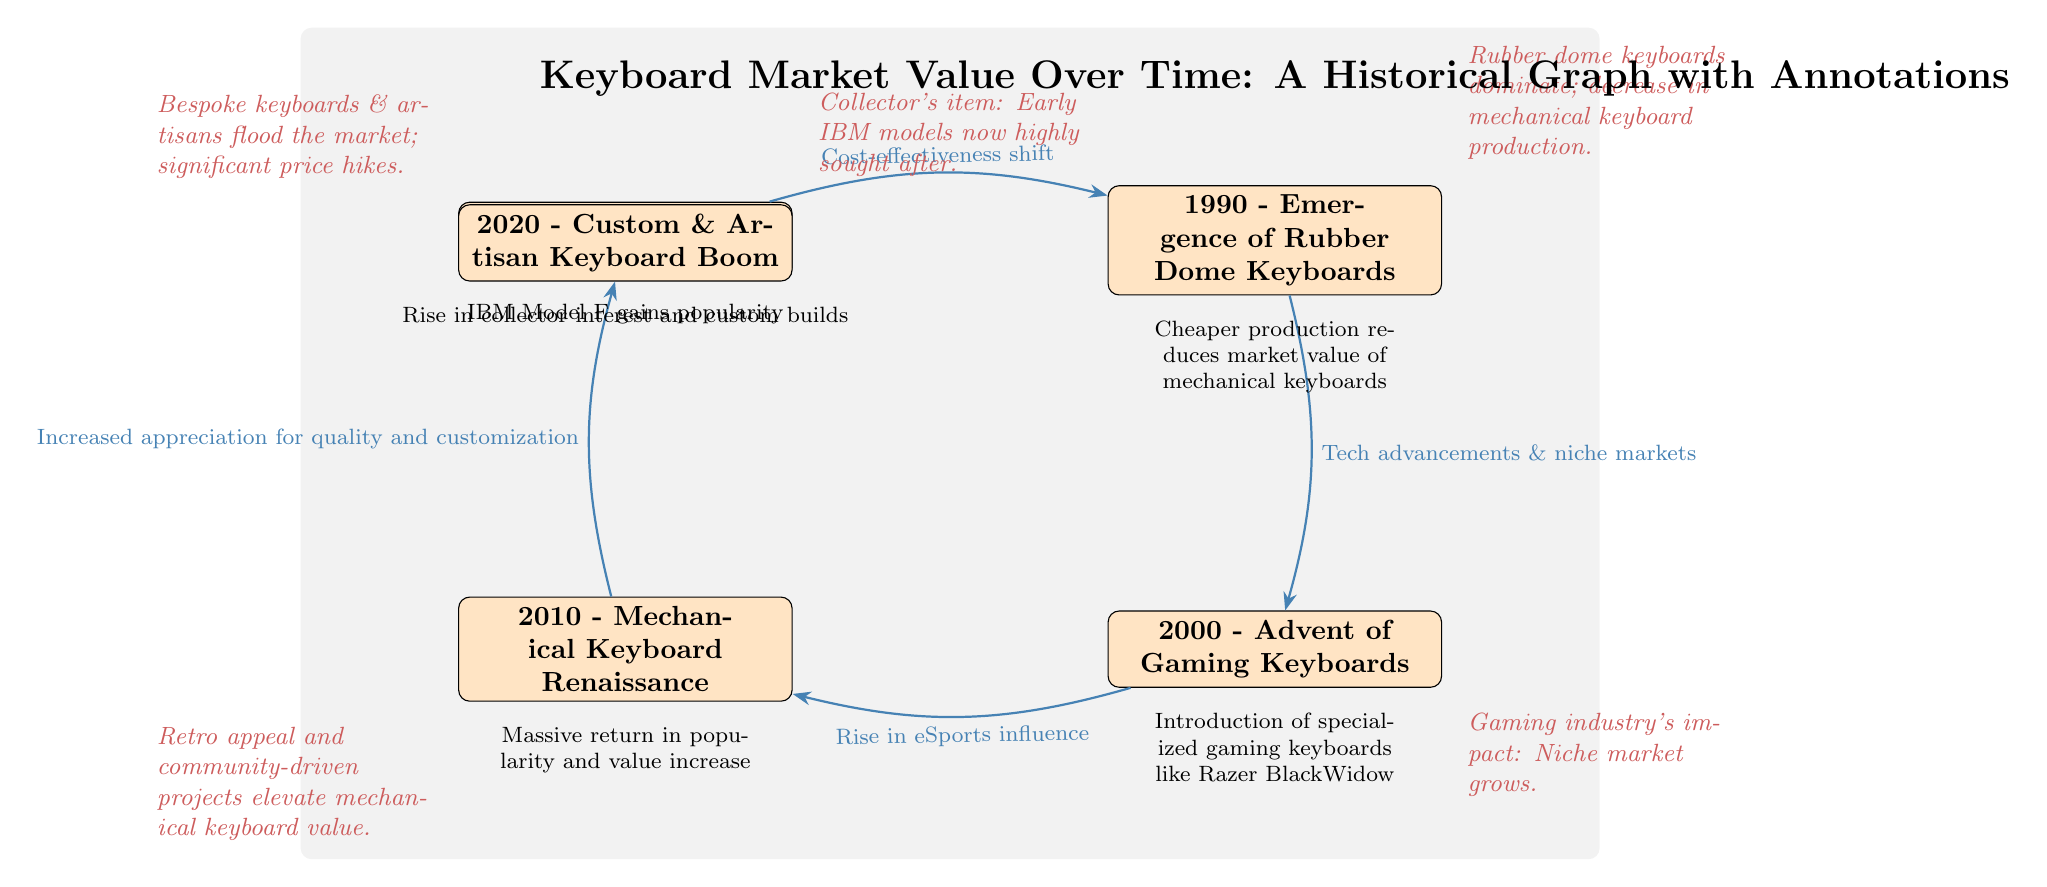What year marks the rise of mechanical keyboards? The diagram indicates 1980 as the year when mechanical keyboards began to rise in popularity.
Answer: 1980 How many nodes are displayed in the diagram? The diagram contains five nodes representing different years related to keyboard market trends.
Answer: 5 What keyword describes the market shift in 1990? The edge connecting 1980 to 1990 indicates a "Cost-effectiveness shift," which characterizes the market trend during that time.
Answer: Cost-effectiveness shift Which keyboard type emerged in the year 2000? The annotation next to the 2000 node states that there was an advent of gaming keyboards during that year.
Answer: Gaming Keyboards What significant market factor influenced keyboard values in 2010? The diagram's edge from 2000 to 2010 shows that the rise in eSports influence significantly impacted keyboard values during this period.
Answer: eSports influence What is noted about early IBM models? The annotation near 1980 highlights that early IBM models became highly sought after as collector's items.
Answer: Highly sought after Which event led to a value increase in mechanical keyboards around 2010? The edge connecting 2010 highlights that the increased appreciation for quality and customization raised the value of mechanical keyboards.
Answer: Increased appreciation for quality and customization How has the market changed by 2020 according to the annotations? The 2020 annotation points out that the market saw a flood of bespoke keyboards and artisans, leading to significant price hikes.
Answer: Significant price hikes What trend influenced the market after 2010? The diagram notes that, after 2010, there was a massive return in popularity and an increase in value for mechanical keyboards.
Answer: Massive return in popularity and value increase 